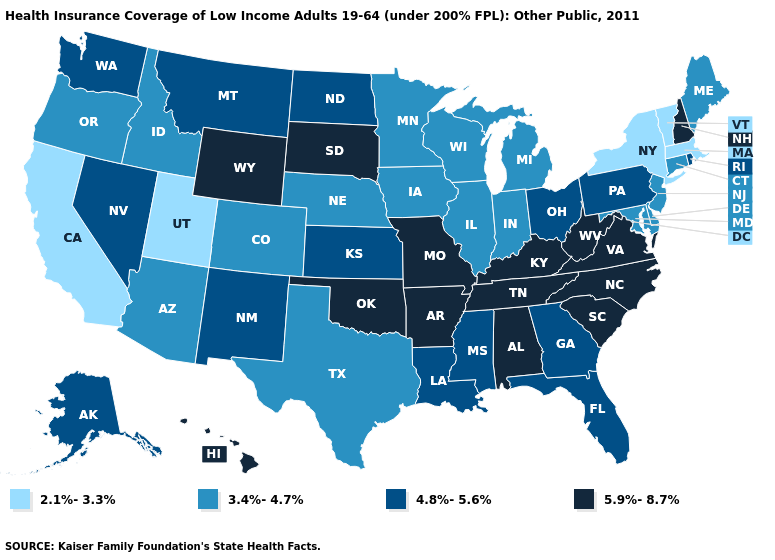Does Texas have the lowest value in the USA?
Short answer required. No. Name the states that have a value in the range 4.8%-5.6%?
Give a very brief answer. Alaska, Florida, Georgia, Kansas, Louisiana, Mississippi, Montana, Nevada, New Mexico, North Dakota, Ohio, Pennsylvania, Rhode Island, Washington. Does Indiana have a higher value than Washington?
Write a very short answer. No. Which states have the highest value in the USA?
Be succinct. Alabama, Arkansas, Hawaii, Kentucky, Missouri, New Hampshire, North Carolina, Oklahoma, South Carolina, South Dakota, Tennessee, Virginia, West Virginia, Wyoming. Name the states that have a value in the range 3.4%-4.7%?
Keep it brief. Arizona, Colorado, Connecticut, Delaware, Idaho, Illinois, Indiana, Iowa, Maine, Maryland, Michigan, Minnesota, Nebraska, New Jersey, Oregon, Texas, Wisconsin. Does West Virginia have a lower value than North Carolina?
Answer briefly. No. What is the highest value in the USA?
Concise answer only. 5.9%-8.7%. Name the states that have a value in the range 5.9%-8.7%?
Write a very short answer. Alabama, Arkansas, Hawaii, Kentucky, Missouri, New Hampshire, North Carolina, Oklahoma, South Carolina, South Dakota, Tennessee, Virginia, West Virginia, Wyoming. Name the states that have a value in the range 4.8%-5.6%?
Quick response, please. Alaska, Florida, Georgia, Kansas, Louisiana, Mississippi, Montana, Nevada, New Mexico, North Dakota, Ohio, Pennsylvania, Rhode Island, Washington. Does Nevada have the same value as Michigan?
Give a very brief answer. No. What is the value of Michigan?
Concise answer only. 3.4%-4.7%. Among the states that border California , does Nevada have the highest value?
Write a very short answer. Yes. What is the value of Iowa?
Concise answer only. 3.4%-4.7%. What is the lowest value in the USA?
Write a very short answer. 2.1%-3.3%. Among the states that border Iowa , which have the highest value?
Be succinct. Missouri, South Dakota. 